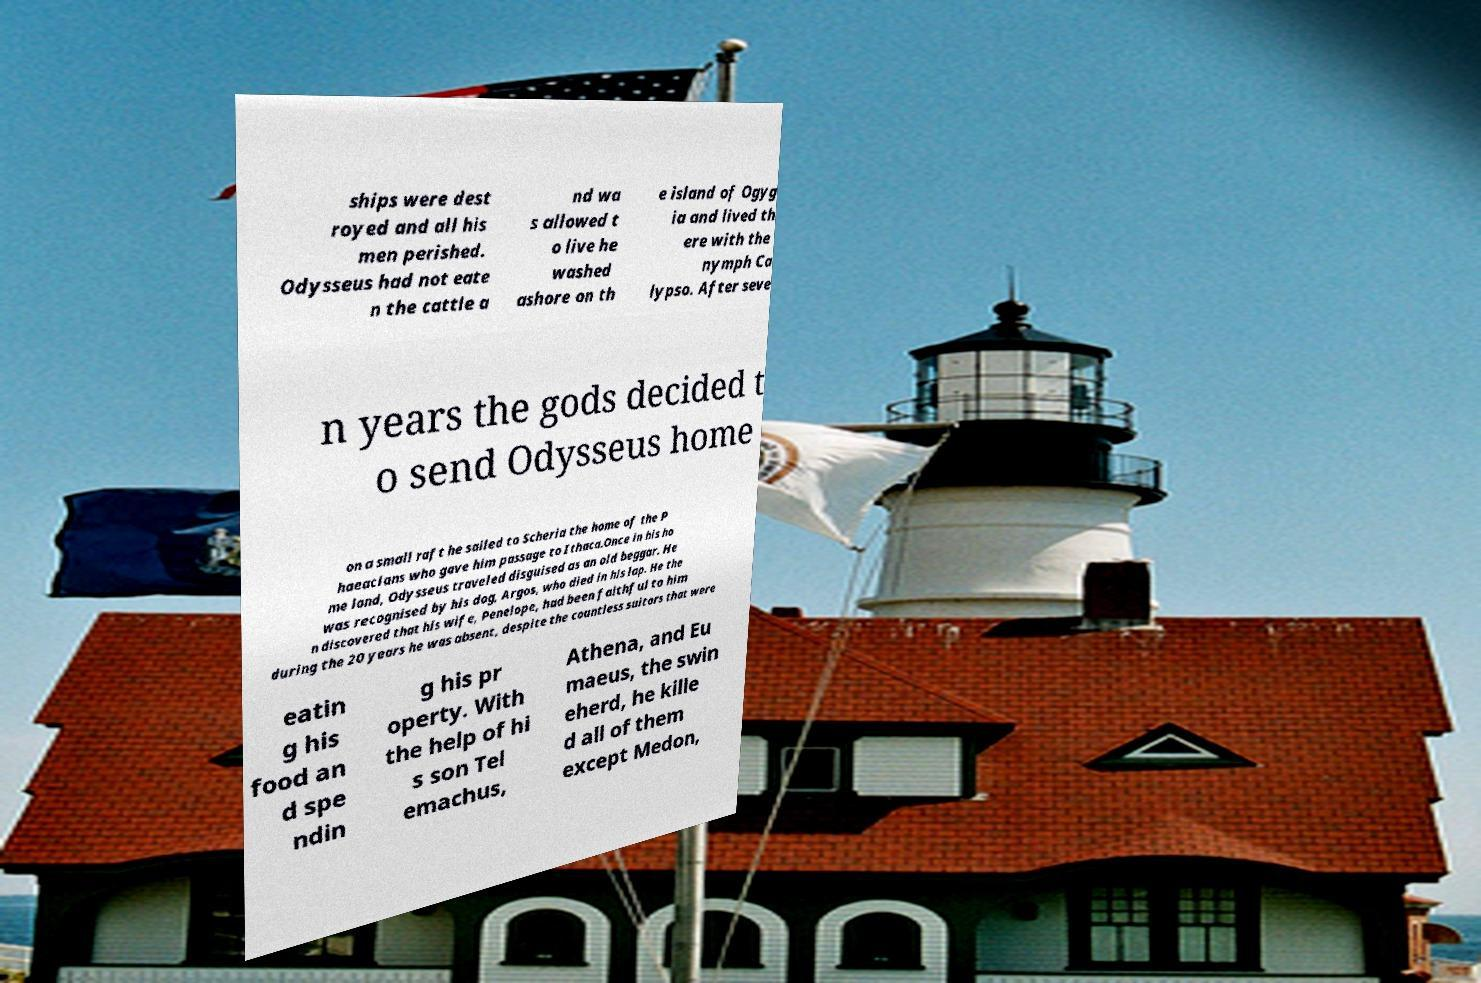For documentation purposes, I need the text within this image transcribed. Could you provide that? ships were dest royed and all his men perished. Odysseus had not eate n the cattle a nd wa s allowed t o live he washed ashore on th e island of Ogyg ia and lived th ere with the nymph Ca lypso. After seve n years the gods decided t o send Odysseus home on a small raft he sailed to Scheria the home of the P haeacians who gave him passage to Ithaca.Once in his ho me land, Odysseus traveled disguised as an old beggar. He was recognised by his dog, Argos, who died in his lap. He the n discovered that his wife, Penelope, had been faithful to him during the 20 years he was absent, despite the countless suitors that were eatin g his food an d spe ndin g his pr operty. With the help of hi s son Tel emachus, Athena, and Eu maeus, the swin eherd, he kille d all of them except Medon, 